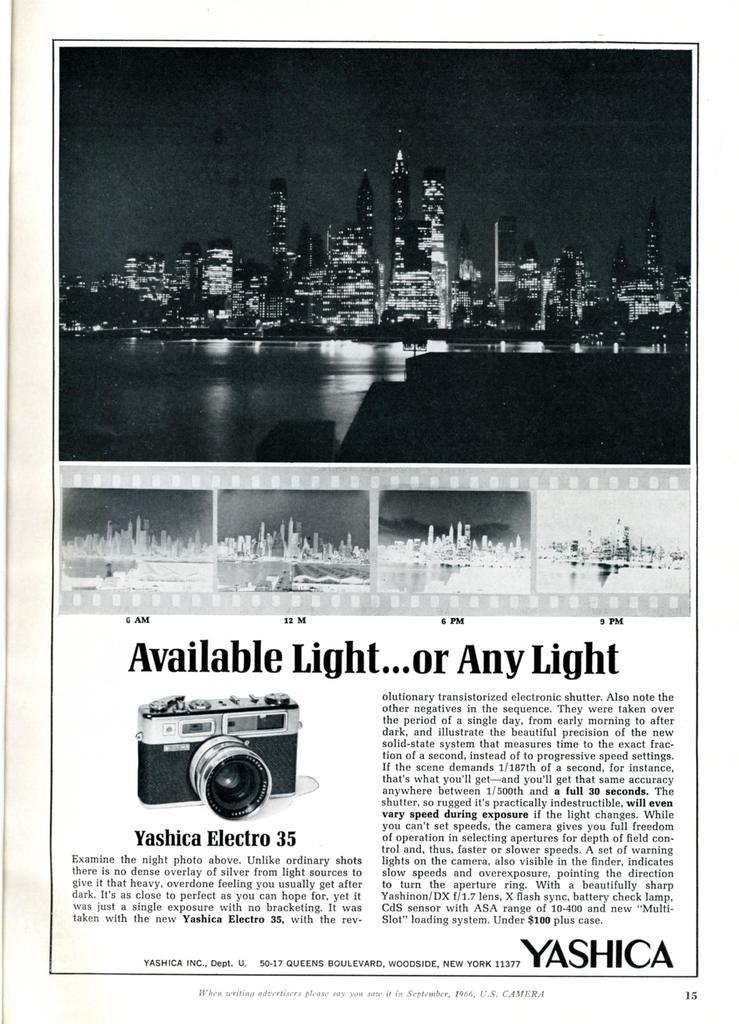<image>
Offer a succinct explanation of the picture presented. a page out of a book that says 'available light...or any light' on it 